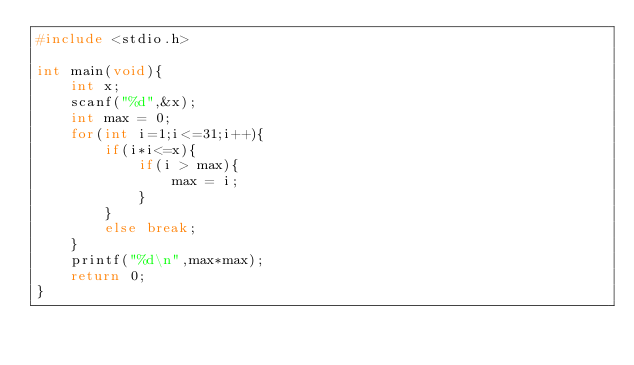<code> <loc_0><loc_0><loc_500><loc_500><_C_>#include <stdio.h>

int main(void){
    int x;
    scanf("%d",&x);
    int max = 0;
    for(int i=1;i<=31;i++){
        if(i*i<=x){
            if(i > max){
                max = i;
            }
        }
        else break;
    }
    printf("%d\n",max*max);
    return 0;
}</code> 